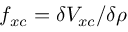Convert formula to latex. <formula><loc_0><loc_0><loc_500><loc_500>f _ { x c } = \delta V _ { x c } / \delta \rho</formula> 